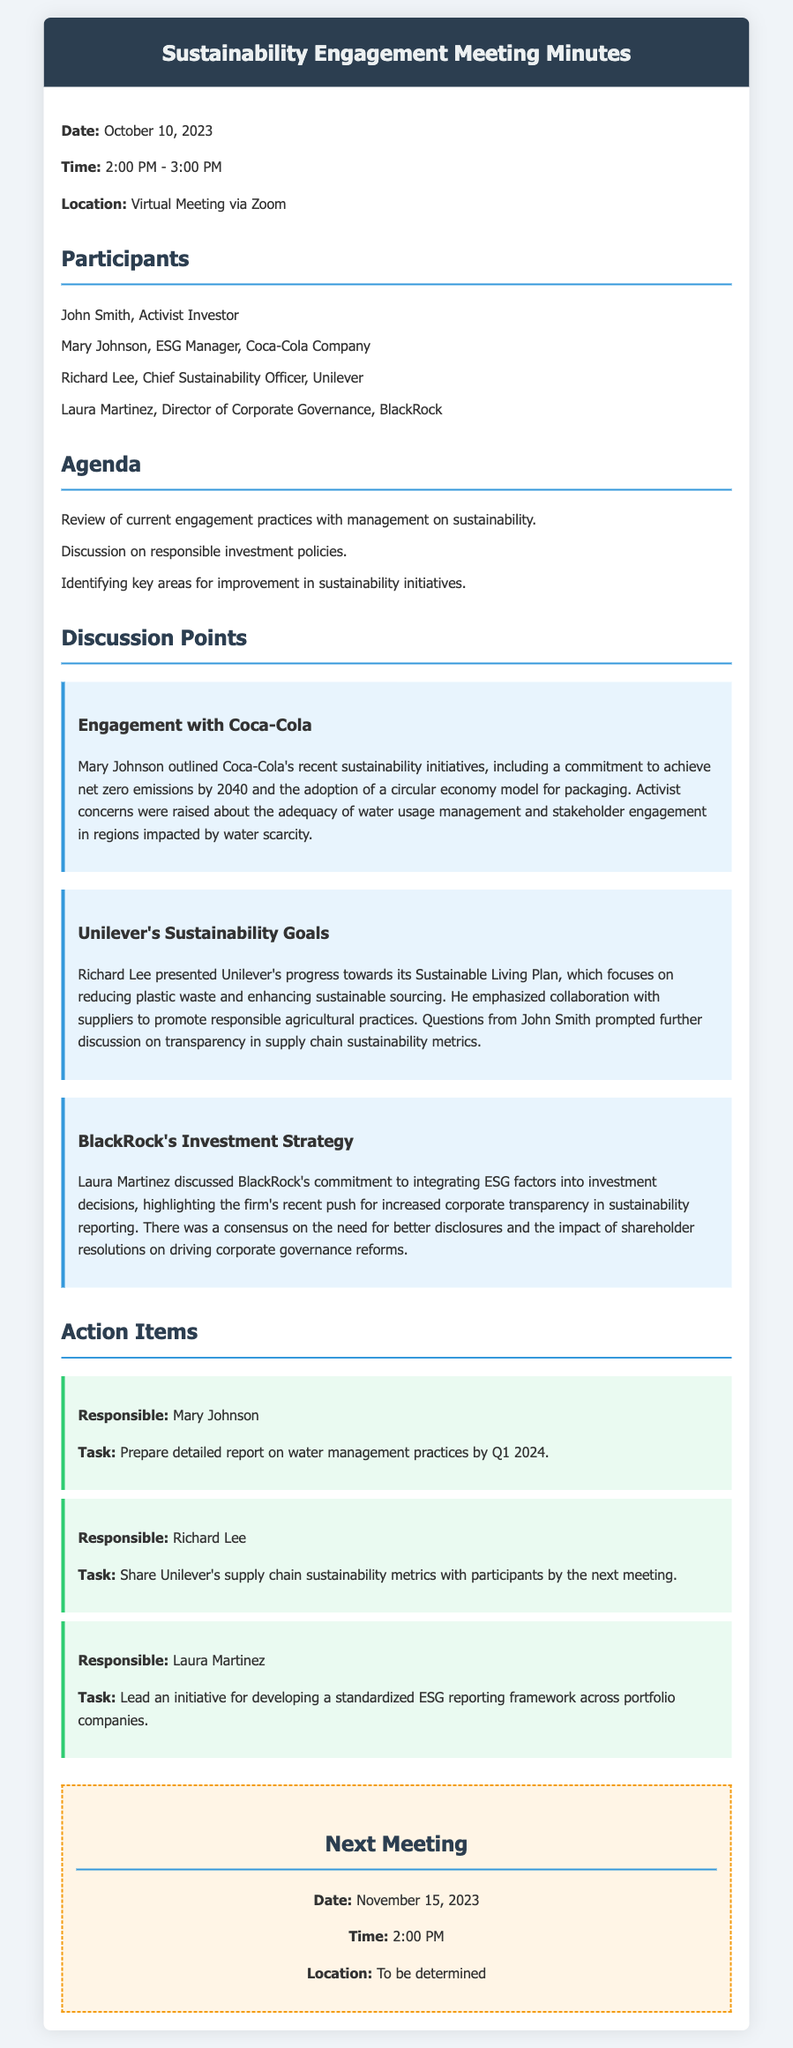What is the date of the meeting? The date of the meeting is specified in the document as October 10, 2023.
Answer: October 10, 2023 Who is the Chief Sustainability Officer of Unilever? The Chief Sustainability Officer mentioned in the document is Richard Lee.
Answer: Richard Lee What sustainability target did Coca-Cola commit to? Coca-Cola's commitment outlined in the meeting was to achieve net zero emissions by 2040.
Answer: net zero emissions by 2040 What should Mary Johnson prepare by Q1 2024? The document states that Mary Johnson is tasked with preparing a detailed report on water management practices by Q1 2024.
Answer: detailed report on water management practices What is the main focus of Unilever's Sustainable Living Plan? The focus of Unilever's Sustainable Living Plan, as presented, is on reducing plastic waste and enhancing sustainable sourcing.
Answer: reducing plastic waste and enhancing sustainable sourcing When is the next meeting scheduled? According to the document, the next meeting is scheduled for November 15, 2023.
Answer: November 15, 2023 What initiative will Laura Martinez lead? Laura Martinez will lead an initiative for developing a standardized ESG reporting framework across portfolio companies.
Answer: developing a standardized ESG reporting framework What was a concern raised regarding Coca-Cola's sustainability practices? A concern raised was about the adequacy of water usage management and stakeholder engagement regarding water scarcity.
Answer: adequacy of water usage management and stakeholder engagement What does BlackRock emphasize in its investment strategy? BlackRock emphasizes integrating ESG factors into investment decisions and increasing corporate transparency in sustainability reporting.
Answer: integrating ESG factors into investment decisions and increased corporate transparency 